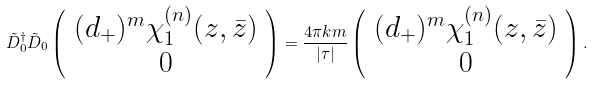<formula> <loc_0><loc_0><loc_500><loc_500>\tilde { D } _ { 0 } ^ { \dagger } \tilde { D } _ { 0 } \left ( \begin{array} { c } ( d _ { + } ) ^ { m } \chi _ { 1 } ^ { ( n ) } ( z , \bar { z } ) \\ 0 \end{array} \right ) = \frac { 4 \pi k m } { | \tau | } \left ( \begin{array} { c } ( d _ { + } ) ^ { m } \chi _ { 1 } ^ { ( n ) } ( z , \bar { z } ) \\ 0 \end{array} \right ) .</formula> 